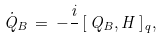<formula> <loc_0><loc_0><loc_500><loc_500>\dot { Q } _ { B } \, = \, - \frac { i } { } \, [ \, Q _ { B } , H \, ] _ { q } ,</formula> 